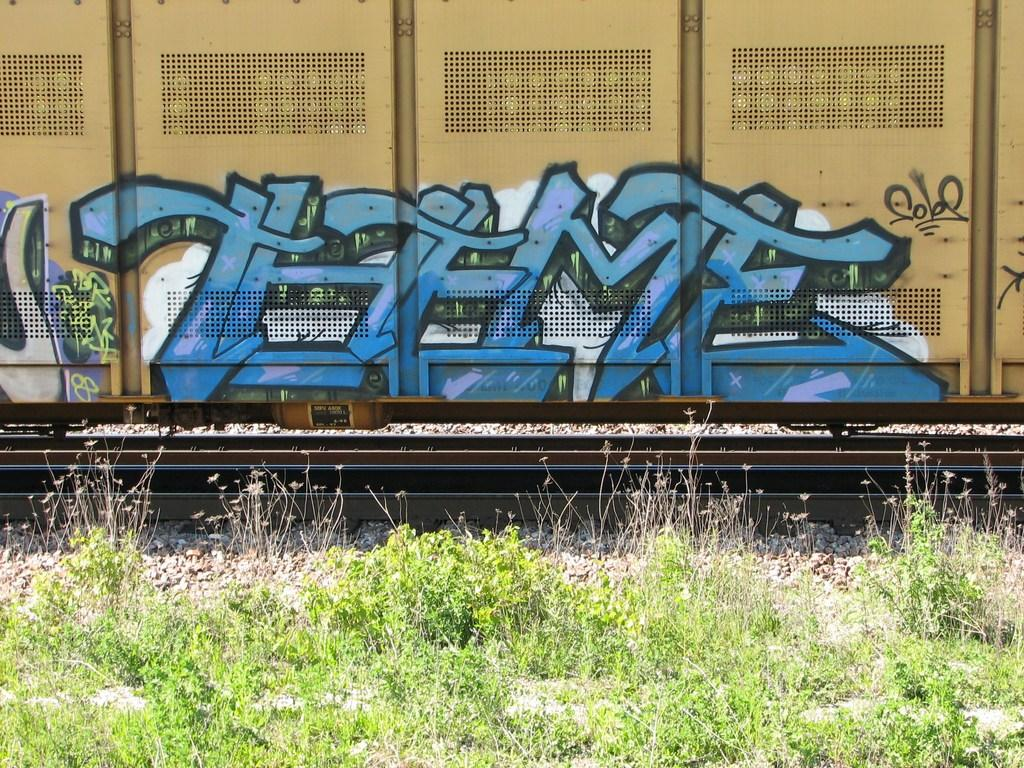<image>
Write a terse but informative summary of the picture. The train car has graffiti with the letters THFMF on it. 